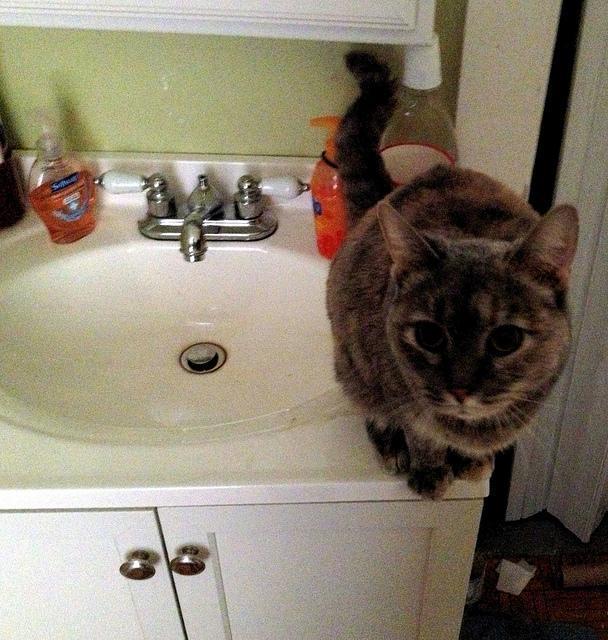How many bottles are there?
Give a very brief answer. 3. 